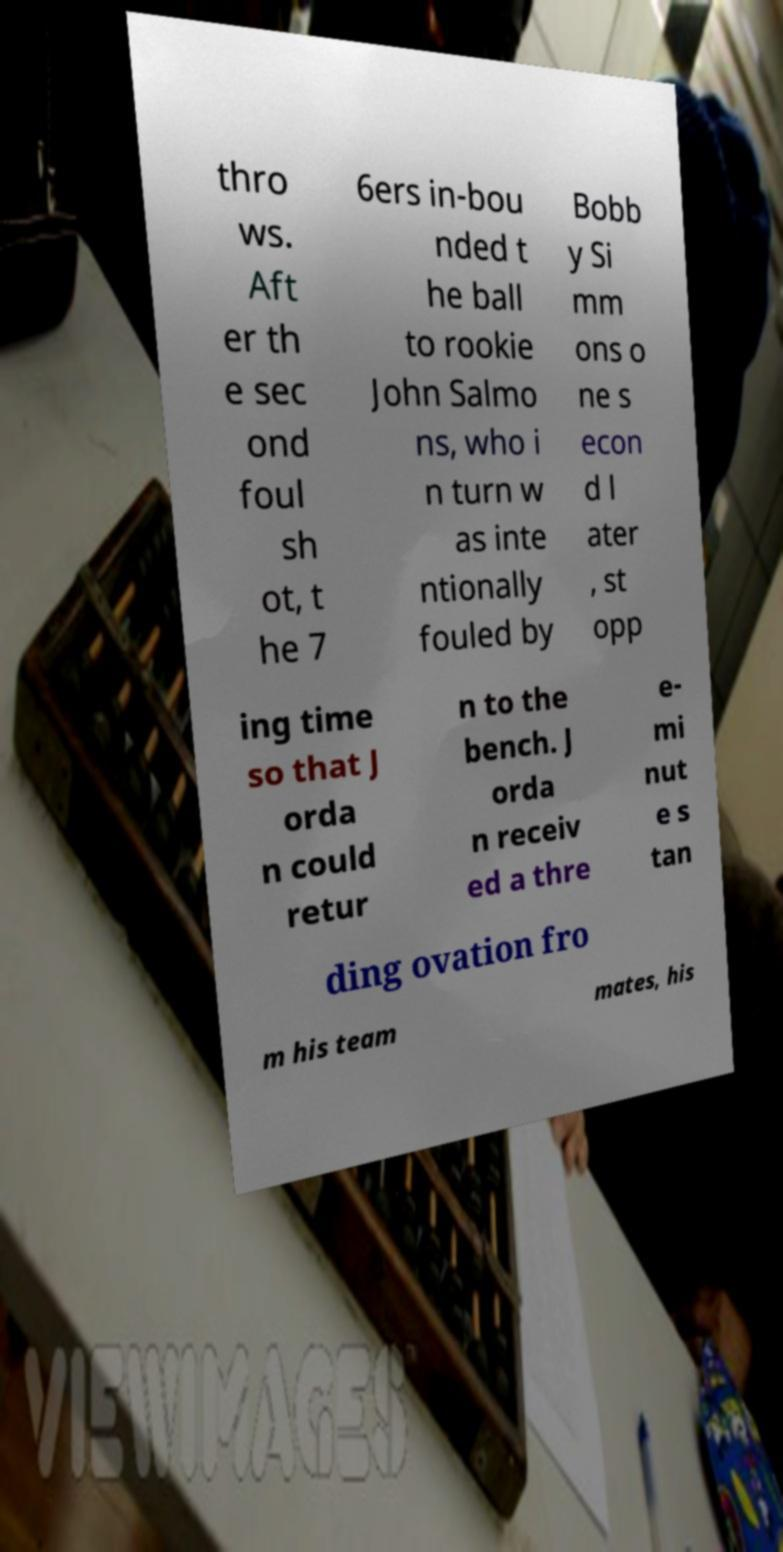Could you assist in decoding the text presented in this image and type it out clearly? thro ws. Aft er th e sec ond foul sh ot, t he 7 6ers in-bou nded t he ball to rookie John Salmo ns, who i n turn w as inte ntionally fouled by Bobb y Si mm ons o ne s econ d l ater , st opp ing time so that J orda n could retur n to the bench. J orda n receiv ed a thre e- mi nut e s tan ding ovation fro m his team mates, his 